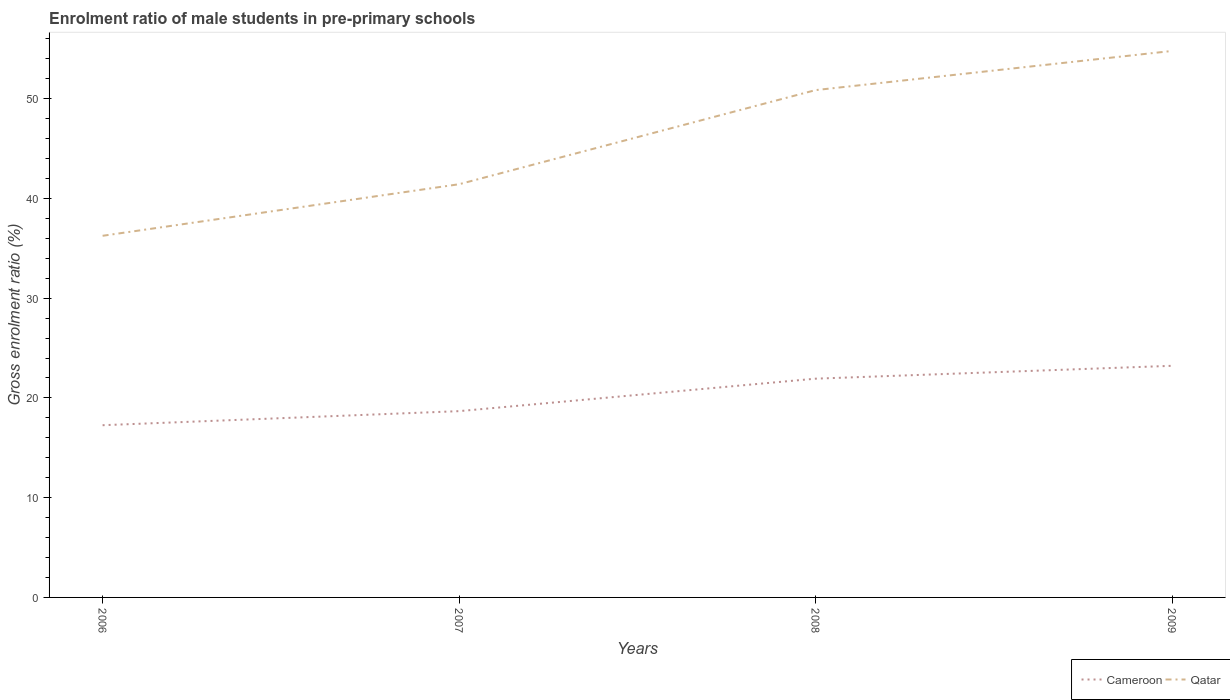Is the number of lines equal to the number of legend labels?
Give a very brief answer. Yes. Across all years, what is the maximum enrolment ratio of male students in pre-primary schools in Cameroon?
Provide a short and direct response. 17.26. In which year was the enrolment ratio of male students in pre-primary schools in Qatar maximum?
Provide a succinct answer. 2006. What is the total enrolment ratio of male students in pre-primary schools in Cameroon in the graph?
Keep it short and to the point. -4.67. What is the difference between the highest and the second highest enrolment ratio of male students in pre-primary schools in Cameroon?
Offer a terse response. 5.96. What is the difference between the highest and the lowest enrolment ratio of male students in pre-primary schools in Cameroon?
Make the answer very short. 2. How many lines are there?
Provide a short and direct response. 2. How many years are there in the graph?
Your response must be concise. 4. Does the graph contain grids?
Your answer should be very brief. No. What is the title of the graph?
Your answer should be very brief. Enrolment ratio of male students in pre-primary schools. What is the Gross enrolment ratio (%) of Cameroon in 2006?
Keep it short and to the point. 17.26. What is the Gross enrolment ratio (%) of Qatar in 2006?
Offer a very short reply. 36.25. What is the Gross enrolment ratio (%) in Cameroon in 2007?
Offer a terse response. 18.67. What is the Gross enrolment ratio (%) in Qatar in 2007?
Keep it short and to the point. 41.42. What is the Gross enrolment ratio (%) of Cameroon in 2008?
Offer a very short reply. 21.93. What is the Gross enrolment ratio (%) in Qatar in 2008?
Your answer should be compact. 50.85. What is the Gross enrolment ratio (%) in Cameroon in 2009?
Offer a terse response. 23.22. What is the Gross enrolment ratio (%) of Qatar in 2009?
Offer a terse response. 54.78. Across all years, what is the maximum Gross enrolment ratio (%) of Cameroon?
Your answer should be very brief. 23.22. Across all years, what is the maximum Gross enrolment ratio (%) of Qatar?
Give a very brief answer. 54.78. Across all years, what is the minimum Gross enrolment ratio (%) in Cameroon?
Your answer should be compact. 17.26. Across all years, what is the minimum Gross enrolment ratio (%) of Qatar?
Provide a succinct answer. 36.25. What is the total Gross enrolment ratio (%) in Cameroon in the graph?
Offer a terse response. 81.08. What is the total Gross enrolment ratio (%) of Qatar in the graph?
Provide a succinct answer. 183.3. What is the difference between the Gross enrolment ratio (%) of Cameroon in 2006 and that in 2007?
Your answer should be compact. -1.41. What is the difference between the Gross enrolment ratio (%) in Qatar in 2006 and that in 2007?
Your answer should be compact. -5.17. What is the difference between the Gross enrolment ratio (%) of Cameroon in 2006 and that in 2008?
Your response must be concise. -4.67. What is the difference between the Gross enrolment ratio (%) of Qatar in 2006 and that in 2008?
Provide a succinct answer. -14.6. What is the difference between the Gross enrolment ratio (%) in Cameroon in 2006 and that in 2009?
Your answer should be very brief. -5.96. What is the difference between the Gross enrolment ratio (%) in Qatar in 2006 and that in 2009?
Ensure brevity in your answer.  -18.53. What is the difference between the Gross enrolment ratio (%) of Cameroon in 2007 and that in 2008?
Offer a very short reply. -3.26. What is the difference between the Gross enrolment ratio (%) in Qatar in 2007 and that in 2008?
Offer a terse response. -9.43. What is the difference between the Gross enrolment ratio (%) in Cameroon in 2007 and that in 2009?
Offer a terse response. -4.54. What is the difference between the Gross enrolment ratio (%) of Qatar in 2007 and that in 2009?
Offer a terse response. -13.36. What is the difference between the Gross enrolment ratio (%) in Cameroon in 2008 and that in 2009?
Give a very brief answer. -1.29. What is the difference between the Gross enrolment ratio (%) of Qatar in 2008 and that in 2009?
Offer a terse response. -3.92. What is the difference between the Gross enrolment ratio (%) in Cameroon in 2006 and the Gross enrolment ratio (%) in Qatar in 2007?
Offer a terse response. -24.16. What is the difference between the Gross enrolment ratio (%) of Cameroon in 2006 and the Gross enrolment ratio (%) of Qatar in 2008?
Offer a very short reply. -33.59. What is the difference between the Gross enrolment ratio (%) in Cameroon in 2006 and the Gross enrolment ratio (%) in Qatar in 2009?
Give a very brief answer. -37.52. What is the difference between the Gross enrolment ratio (%) of Cameroon in 2007 and the Gross enrolment ratio (%) of Qatar in 2008?
Keep it short and to the point. -32.18. What is the difference between the Gross enrolment ratio (%) in Cameroon in 2007 and the Gross enrolment ratio (%) in Qatar in 2009?
Provide a short and direct response. -36.1. What is the difference between the Gross enrolment ratio (%) of Cameroon in 2008 and the Gross enrolment ratio (%) of Qatar in 2009?
Ensure brevity in your answer.  -32.85. What is the average Gross enrolment ratio (%) of Cameroon per year?
Keep it short and to the point. 20.27. What is the average Gross enrolment ratio (%) of Qatar per year?
Make the answer very short. 45.83. In the year 2006, what is the difference between the Gross enrolment ratio (%) of Cameroon and Gross enrolment ratio (%) of Qatar?
Your answer should be compact. -18.99. In the year 2007, what is the difference between the Gross enrolment ratio (%) of Cameroon and Gross enrolment ratio (%) of Qatar?
Your answer should be very brief. -22.75. In the year 2008, what is the difference between the Gross enrolment ratio (%) of Cameroon and Gross enrolment ratio (%) of Qatar?
Your answer should be compact. -28.93. In the year 2009, what is the difference between the Gross enrolment ratio (%) in Cameroon and Gross enrolment ratio (%) in Qatar?
Your response must be concise. -31.56. What is the ratio of the Gross enrolment ratio (%) in Cameroon in 2006 to that in 2007?
Your response must be concise. 0.92. What is the ratio of the Gross enrolment ratio (%) of Qatar in 2006 to that in 2007?
Provide a short and direct response. 0.88. What is the ratio of the Gross enrolment ratio (%) in Cameroon in 2006 to that in 2008?
Your answer should be very brief. 0.79. What is the ratio of the Gross enrolment ratio (%) in Qatar in 2006 to that in 2008?
Provide a short and direct response. 0.71. What is the ratio of the Gross enrolment ratio (%) of Cameroon in 2006 to that in 2009?
Offer a terse response. 0.74. What is the ratio of the Gross enrolment ratio (%) of Qatar in 2006 to that in 2009?
Give a very brief answer. 0.66. What is the ratio of the Gross enrolment ratio (%) of Cameroon in 2007 to that in 2008?
Your answer should be very brief. 0.85. What is the ratio of the Gross enrolment ratio (%) in Qatar in 2007 to that in 2008?
Your answer should be very brief. 0.81. What is the ratio of the Gross enrolment ratio (%) in Cameroon in 2007 to that in 2009?
Your response must be concise. 0.8. What is the ratio of the Gross enrolment ratio (%) in Qatar in 2007 to that in 2009?
Make the answer very short. 0.76. What is the ratio of the Gross enrolment ratio (%) in Cameroon in 2008 to that in 2009?
Offer a very short reply. 0.94. What is the ratio of the Gross enrolment ratio (%) of Qatar in 2008 to that in 2009?
Your answer should be very brief. 0.93. What is the difference between the highest and the second highest Gross enrolment ratio (%) in Cameroon?
Provide a succinct answer. 1.29. What is the difference between the highest and the second highest Gross enrolment ratio (%) in Qatar?
Give a very brief answer. 3.92. What is the difference between the highest and the lowest Gross enrolment ratio (%) of Cameroon?
Give a very brief answer. 5.96. What is the difference between the highest and the lowest Gross enrolment ratio (%) in Qatar?
Your answer should be very brief. 18.53. 